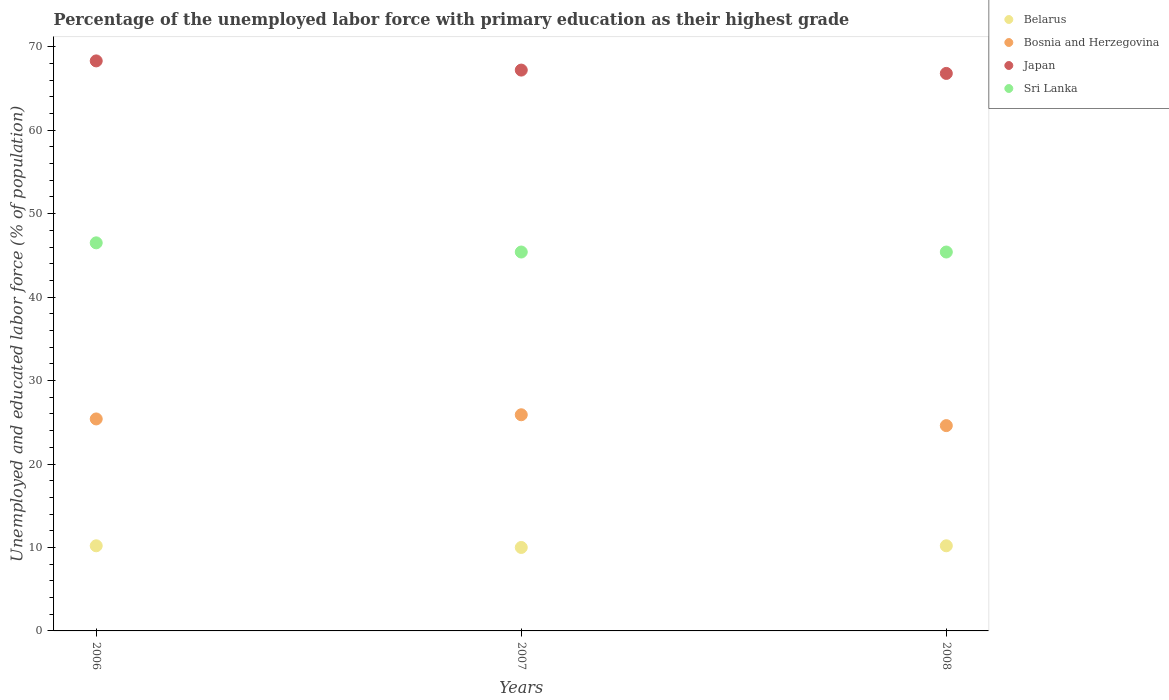Is the number of dotlines equal to the number of legend labels?
Keep it short and to the point. Yes. What is the percentage of the unemployed labor force with primary education in Belarus in 2008?
Keep it short and to the point. 10.2. Across all years, what is the maximum percentage of the unemployed labor force with primary education in Belarus?
Give a very brief answer. 10.2. Across all years, what is the minimum percentage of the unemployed labor force with primary education in Bosnia and Herzegovina?
Your answer should be compact. 24.6. In which year was the percentage of the unemployed labor force with primary education in Belarus maximum?
Give a very brief answer. 2006. What is the total percentage of the unemployed labor force with primary education in Bosnia and Herzegovina in the graph?
Your response must be concise. 75.9. What is the difference between the percentage of the unemployed labor force with primary education in Bosnia and Herzegovina in 2006 and that in 2008?
Make the answer very short. 0.8. What is the difference between the percentage of the unemployed labor force with primary education in Sri Lanka in 2007 and the percentage of the unemployed labor force with primary education in Bosnia and Herzegovina in 2008?
Provide a short and direct response. 20.8. What is the average percentage of the unemployed labor force with primary education in Bosnia and Herzegovina per year?
Offer a very short reply. 25.3. In the year 2008, what is the difference between the percentage of the unemployed labor force with primary education in Bosnia and Herzegovina and percentage of the unemployed labor force with primary education in Sri Lanka?
Your response must be concise. -20.8. What is the difference between the highest and the second highest percentage of the unemployed labor force with primary education in Japan?
Make the answer very short. 1.1. What is the difference between the highest and the lowest percentage of the unemployed labor force with primary education in Belarus?
Your answer should be compact. 0.2. In how many years, is the percentage of the unemployed labor force with primary education in Japan greater than the average percentage of the unemployed labor force with primary education in Japan taken over all years?
Ensure brevity in your answer.  1. Is the sum of the percentage of the unemployed labor force with primary education in Japan in 2006 and 2008 greater than the maximum percentage of the unemployed labor force with primary education in Bosnia and Herzegovina across all years?
Offer a very short reply. Yes. Is it the case that in every year, the sum of the percentage of the unemployed labor force with primary education in Japan and percentage of the unemployed labor force with primary education in Sri Lanka  is greater than the percentage of the unemployed labor force with primary education in Belarus?
Offer a very short reply. Yes. Is the percentage of the unemployed labor force with primary education in Belarus strictly less than the percentage of the unemployed labor force with primary education in Sri Lanka over the years?
Your answer should be very brief. Yes. How many dotlines are there?
Offer a terse response. 4. How many years are there in the graph?
Offer a very short reply. 3. What is the difference between two consecutive major ticks on the Y-axis?
Your response must be concise. 10. Does the graph contain any zero values?
Ensure brevity in your answer.  No. Where does the legend appear in the graph?
Your answer should be compact. Top right. What is the title of the graph?
Keep it short and to the point. Percentage of the unemployed labor force with primary education as their highest grade. Does "Tajikistan" appear as one of the legend labels in the graph?
Make the answer very short. No. What is the label or title of the X-axis?
Give a very brief answer. Years. What is the label or title of the Y-axis?
Provide a succinct answer. Unemployed and educated labor force (% of population). What is the Unemployed and educated labor force (% of population) of Belarus in 2006?
Provide a short and direct response. 10.2. What is the Unemployed and educated labor force (% of population) in Bosnia and Herzegovina in 2006?
Provide a short and direct response. 25.4. What is the Unemployed and educated labor force (% of population) of Japan in 2006?
Offer a terse response. 68.3. What is the Unemployed and educated labor force (% of population) of Sri Lanka in 2006?
Ensure brevity in your answer.  46.5. What is the Unemployed and educated labor force (% of population) of Belarus in 2007?
Your answer should be very brief. 10. What is the Unemployed and educated labor force (% of population) in Bosnia and Herzegovina in 2007?
Your answer should be very brief. 25.9. What is the Unemployed and educated labor force (% of population) of Japan in 2007?
Make the answer very short. 67.2. What is the Unemployed and educated labor force (% of population) of Sri Lanka in 2007?
Provide a succinct answer. 45.4. What is the Unemployed and educated labor force (% of population) in Belarus in 2008?
Your response must be concise. 10.2. What is the Unemployed and educated labor force (% of population) of Bosnia and Herzegovina in 2008?
Keep it short and to the point. 24.6. What is the Unemployed and educated labor force (% of population) of Japan in 2008?
Your answer should be compact. 66.8. What is the Unemployed and educated labor force (% of population) of Sri Lanka in 2008?
Keep it short and to the point. 45.4. Across all years, what is the maximum Unemployed and educated labor force (% of population) in Belarus?
Ensure brevity in your answer.  10.2. Across all years, what is the maximum Unemployed and educated labor force (% of population) of Bosnia and Herzegovina?
Keep it short and to the point. 25.9. Across all years, what is the maximum Unemployed and educated labor force (% of population) in Japan?
Your answer should be compact. 68.3. Across all years, what is the maximum Unemployed and educated labor force (% of population) of Sri Lanka?
Provide a succinct answer. 46.5. Across all years, what is the minimum Unemployed and educated labor force (% of population) in Belarus?
Your answer should be compact. 10. Across all years, what is the minimum Unemployed and educated labor force (% of population) of Bosnia and Herzegovina?
Your response must be concise. 24.6. Across all years, what is the minimum Unemployed and educated labor force (% of population) of Japan?
Give a very brief answer. 66.8. Across all years, what is the minimum Unemployed and educated labor force (% of population) of Sri Lanka?
Offer a terse response. 45.4. What is the total Unemployed and educated labor force (% of population) in Belarus in the graph?
Make the answer very short. 30.4. What is the total Unemployed and educated labor force (% of population) in Bosnia and Herzegovina in the graph?
Keep it short and to the point. 75.9. What is the total Unemployed and educated labor force (% of population) of Japan in the graph?
Provide a short and direct response. 202.3. What is the total Unemployed and educated labor force (% of population) of Sri Lanka in the graph?
Your response must be concise. 137.3. What is the difference between the Unemployed and educated labor force (% of population) of Sri Lanka in 2006 and that in 2008?
Your answer should be very brief. 1.1. What is the difference between the Unemployed and educated labor force (% of population) of Bosnia and Herzegovina in 2007 and that in 2008?
Make the answer very short. 1.3. What is the difference between the Unemployed and educated labor force (% of population) of Japan in 2007 and that in 2008?
Offer a terse response. 0.4. What is the difference between the Unemployed and educated labor force (% of population) of Belarus in 2006 and the Unemployed and educated labor force (% of population) of Bosnia and Herzegovina in 2007?
Keep it short and to the point. -15.7. What is the difference between the Unemployed and educated labor force (% of population) of Belarus in 2006 and the Unemployed and educated labor force (% of population) of Japan in 2007?
Keep it short and to the point. -57. What is the difference between the Unemployed and educated labor force (% of population) of Belarus in 2006 and the Unemployed and educated labor force (% of population) of Sri Lanka in 2007?
Offer a very short reply. -35.2. What is the difference between the Unemployed and educated labor force (% of population) in Bosnia and Herzegovina in 2006 and the Unemployed and educated labor force (% of population) in Japan in 2007?
Make the answer very short. -41.8. What is the difference between the Unemployed and educated labor force (% of population) of Bosnia and Herzegovina in 2006 and the Unemployed and educated labor force (% of population) of Sri Lanka in 2007?
Give a very brief answer. -20. What is the difference between the Unemployed and educated labor force (% of population) of Japan in 2006 and the Unemployed and educated labor force (% of population) of Sri Lanka in 2007?
Provide a short and direct response. 22.9. What is the difference between the Unemployed and educated labor force (% of population) of Belarus in 2006 and the Unemployed and educated labor force (% of population) of Bosnia and Herzegovina in 2008?
Give a very brief answer. -14.4. What is the difference between the Unemployed and educated labor force (% of population) in Belarus in 2006 and the Unemployed and educated labor force (% of population) in Japan in 2008?
Your answer should be very brief. -56.6. What is the difference between the Unemployed and educated labor force (% of population) in Belarus in 2006 and the Unemployed and educated labor force (% of population) in Sri Lanka in 2008?
Provide a short and direct response. -35.2. What is the difference between the Unemployed and educated labor force (% of population) in Bosnia and Herzegovina in 2006 and the Unemployed and educated labor force (% of population) in Japan in 2008?
Make the answer very short. -41.4. What is the difference between the Unemployed and educated labor force (% of population) of Japan in 2006 and the Unemployed and educated labor force (% of population) of Sri Lanka in 2008?
Keep it short and to the point. 22.9. What is the difference between the Unemployed and educated labor force (% of population) in Belarus in 2007 and the Unemployed and educated labor force (% of population) in Bosnia and Herzegovina in 2008?
Offer a terse response. -14.6. What is the difference between the Unemployed and educated labor force (% of population) in Belarus in 2007 and the Unemployed and educated labor force (% of population) in Japan in 2008?
Your answer should be very brief. -56.8. What is the difference between the Unemployed and educated labor force (% of population) of Belarus in 2007 and the Unemployed and educated labor force (% of population) of Sri Lanka in 2008?
Provide a succinct answer. -35.4. What is the difference between the Unemployed and educated labor force (% of population) of Bosnia and Herzegovina in 2007 and the Unemployed and educated labor force (% of population) of Japan in 2008?
Your answer should be compact. -40.9. What is the difference between the Unemployed and educated labor force (% of population) of Bosnia and Herzegovina in 2007 and the Unemployed and educated labor force (% of population) of Sri Lanka in 2008?
Provide a succinct answer. -19.5. What is the difference between the Unemployed and educated labor force (% of population) of Japan in 2007 and the Unemployed and educated labor force (% of population) of Sri Lanka in 2008?
Your response must be concise. 21.8. What is the average Unemployed and educated labor force (% of population) of Belarus per year?
Give a very brief answer. 10.13. What is the average Unemployed and educated labor force (% of population) in Bosnia and Herzegovina per year?
Ensure brevity in your answer.  25.3. What is the average Unemployed and educated labor force (% of population) in Japan per year?
Offer a terse response. 67.43. What is the average Unemployed and educated labor force (% of population) of Sri Lanka per year?
Offer a very short reply. 45.77. In the year 2006, what is the difference between the Unemployed and educated labor force (% of population) in Belarus and Unemployed and educated labor force (% of population) in Bosnia and Herzegovina?
Give a very brief answer. -15.2. In the year 2006, what is the difference between the Unemployed and educated labor force (% of population) of Belarus and Unemployed and educated labor force (% of population) of Japan?
Your response must be concise. -58.1. In the year 2006, what is the difference between the Unemployed and educated labor force (% of population) of Belarus and Unemployed and educated labor force (% of population) of Sri Lanka?
Offer a very short reply. -36.3. In the year 2006, what is the difference between the Unemployed and educated labor force (% of population) in Bosnia and Herzegovina and Unemployed and educated labor force (% of population) in Japan?
Provide a succinct answer. -42.9. In the year 2006, what is the difference between the Unemployed and educated labor force (% of population) in Bosnia and Herzegovina and Unemployed and educated labor force (% of population) in Sri Lanka?
Your answer should be compact. -21.1. In the year 2006, what is the difference between the Unemployed and educated labor force (% of population) of Japan and Unemployed and educated labor force (% of population) of Sri Lanka?
Your answer should be very brief. 21.8. In the year 2007, what is the difference between the Unemployed and educated labor force (% of population) of Belarus and Unemployed and educated labor force (% of population) of Bosnia and Herzegovina?
Offer a terse response. -15.9. In the year 2007, what is the difference between the Unemployed and educated labor force (% of population) in Belarus and Unemployed and educated labor force (% of population) in Japan?
Offer a very short reply. -57.2. In the year 2007, what is the difference between the Unemployed and educated labor force (% of population) of Belarus and Unemployed and educated labor force (% of population) of Sri Lanka?
Provide a short and direct response. -35.4. In the year 2007, what is the difference between the Unemployed and educated labor force (% of population) of Bosnia and Herzegovina and Unemployed and educated labor force (% of population) of Japan?
Make the answer very short. -41.3. In the year 2007, what is the difference between the Unemployed and educated labor force (% of population) of Bosnia and Herzegovina and Unemployed and educated labor force (% of population) of Sri Lanka?
Offer a terse response. -19.5. In the year 2007, what is the difference between the Unemployed and educated labor force (% of population) of Japan and Unemployed and educated labor force (% of population) of Sri Lanka?
Make the answer very short. 21.8. In the year 2008, what is the difference between the Unemployed and educated labor force (% of population) of Belarus and Unemployed and educated labor force (% of population) of Bosnia and Herzegovina?
Give a very brief answer. -14.4. In the year 2008, what is the difference between the Unemployed and educated labor force (% of population) of Belarus and Unemployed and educated labor force (% of population) of Japan?
Your answer should be very brief. -56.6. In the year 2008, what is the difference between the Unemployed and educated labor force (% of population) in Belarus and Unemployed and educated labor force (% of population) in Sri Lanka?
Your response must be concise. -35.2. In the year 2008, what is the difference between the Unemployed and educated labor force (% of population) of Bosnia and Herzegovina and Unemployed and educated labor force (% of population) of Japan?
Keep it short and to the point. -42.2. In the year 2008, what is the difference between the Unemployed and educated labor force (% of population) of Bosnia and Herzegovina and Unemployed and educated labor force (% of population) of Sri Lanka?
Give a very brief answer. -20.8. In the year 2008, what is the difference between the Unemployed and educated labor force (% of population) in Japan and Unemployed and educated labor force (% of population) in Sri Lanka?
Your answer should be compact. 21.4. What is the ratio of the Unemployed and educated labor force (% of population) in Bosnia and Herzegovina in 2006 to that in 2007?
Offer a terse response. 0.98. What is the ratio of the Unemployed and educated labor force (% of population) in Japan in 2006 to that in 2007?
Your response must be concise. 1.02. What is the ratio of the Unemployed and educated labor force (% of population) of Sri Lanka in 2006 to that in 2007?
Give a very brief answer. 1.02. What is the ratio of the Unemployed and educated labor force (% of population) of Belarus in 2006 to that in 2008?
Your answer should be very brief. 1. What is the ratio of the Unemployed and educated labor force (% of population) in Bosnia and Herzegovina in 2006 to that in 2008?
Keep it short and to the point. 1.03. What is the ratio of the Unemployed and educated labor force (% of population) in Japan in 2006 to that in 2008?
Make the answer very short. 1.02. What is the ratio of the Unemployed and educated labor force (% of population) in Sri Lanka in 2006 to that in 2008?
Keep it short and to the point. 1.02. What is the ratio of the Unemployed and educated labor force (% of population) of Belarus in 2007 to that in 2008?
Offer a terse response. 0.98. What is the ratio of the Unemployed and educated labor force (% of population) of Bosnia and Herzegovina in 2007 to that in 2008?
Provide a succinct answer. 1.05. What is the difference between the highest and the second highest Unemployed and educated labor force (% of population) in Bosnia and Herzegovina?
Make the answer very short. 0.5. What is the difference between the highest and the second highest Unemployed and educated labor force (% of population) in Japan?
Give a very brief answer. 1.1. What is the difference between the highest and the lowest Unemployed and educated labor force (% of population) of Sri Lanka?
Your response must be concise. 1.1. 